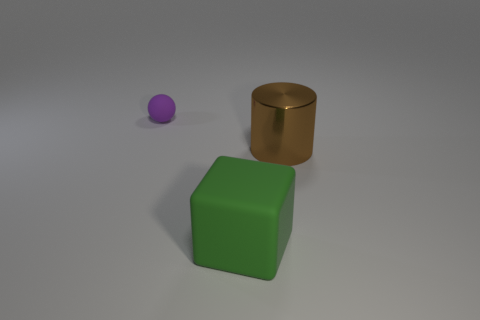Add 1 small yellow matte cylinders. How many objects exist? 4 Subtract all big yellow metal blocks. Subtract all green rubber objects. How many objects are left? 2 Add 2 small purple matte balls. How many small purple matte balls are left? 3 Add 2 big green matte blocks. How many big green matte blocks exist? 3 Subtract 0 yellow spheres. How many objects are left? 3 Subtract all cubes. How many objects are left? 2 